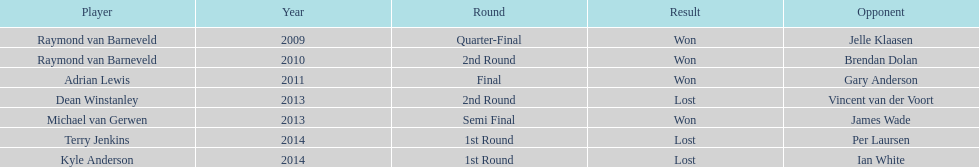Was the winner in 2014 terry jenkins or per laursen? Per Laursen. 